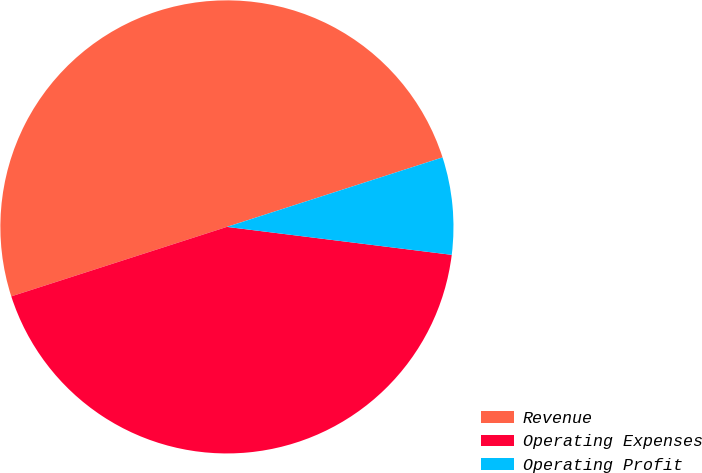Convert chart to OTSL. <chart><loc_0><loc_0><loc_500><loc_500><pie_chart><fcel>Revenue<fcel>Operating Expenses<fcel>Operating Profit<nl><fcel>50.0%<fcel>43.07%<fcel>6.93%<nl></chart> 